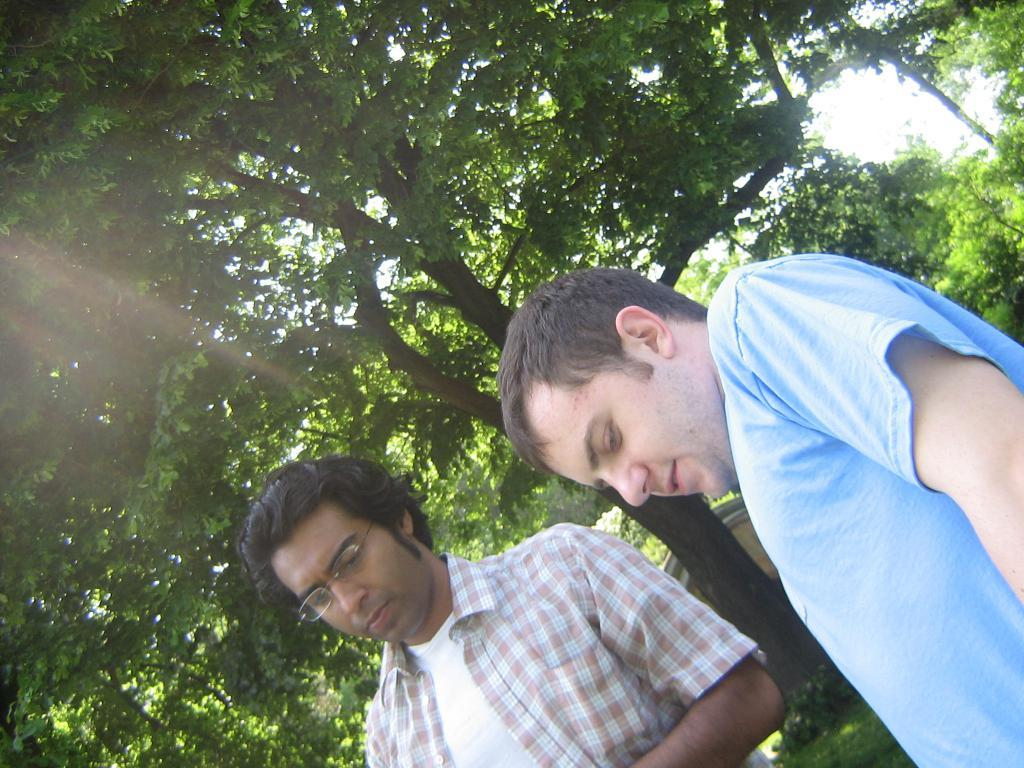What is the main subject in the image? There is a person standing in the image. What type of vegetation can be seen in the image? There are big trees and plants in the image. What is covering the ground in the image? Grass is present on the surface in the image. What object can be seen on the surface in the image? There is an object on the surface in the image. What is visible at the top of the image? The sky is visible at the top of the image. How many kittens are playing with the object on the surface in the image? There are no kittens present in the image; only a person, trees, plants, grass, an object, and the sky are visible. What holiday is being celebrated in the image? There is no indication of a holiday being celebrated in the image. 